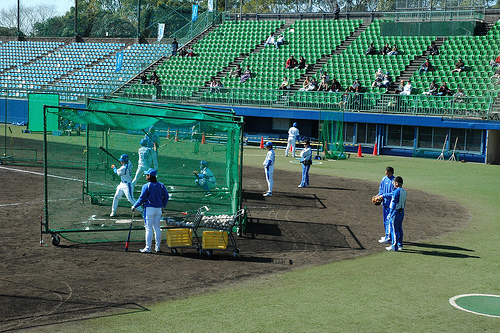<image>
Is the man on the shadow? Yes. Looking at the image, I can see the man is positioned on top of the shadow, with the shadow providing support. Is the cone on the head? No. The cone is not positioned on the head. They may be near each other, but the cone is not supported by or resting on top of the head. 